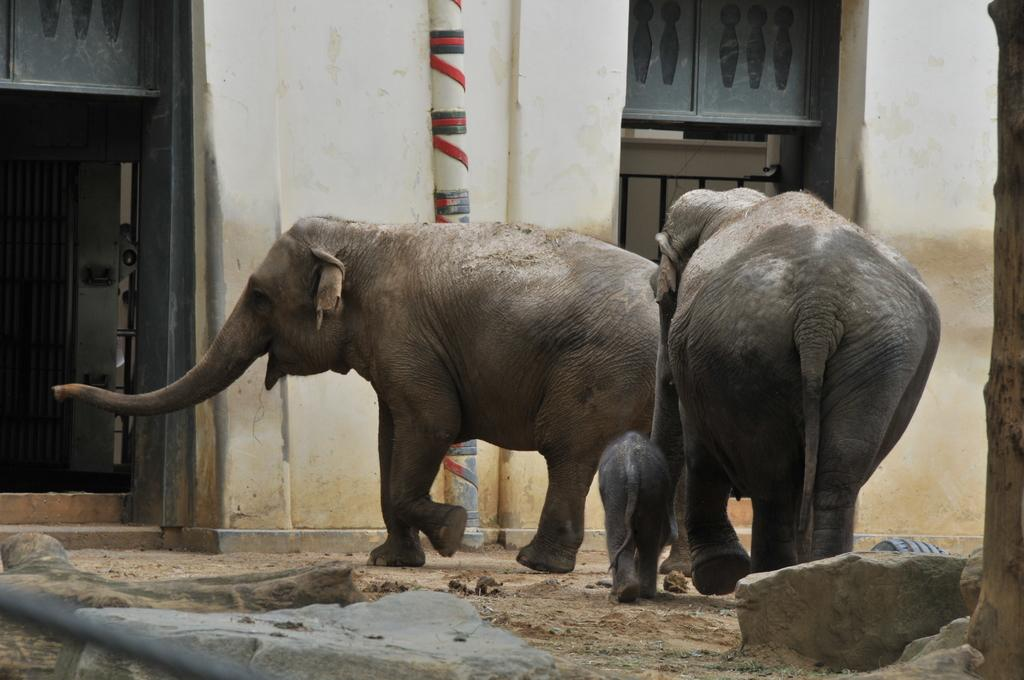How many elephants are in the image? There are three elephants in the image, including two adult elephants and a baby elephant. Can you describe the elephants in the image? There are two adult elephants and a baby elephant in the image. What is visible in the background of the image? There is a building in the background of the image. Can you identify any specific architectural feature in the image? Yes, there is a door visible in the image. What type of leather is being used to make the kettle in the image? There is no kettle present in the image, so it is not possible to determine what type of leather might be used. 